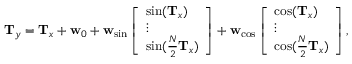Convert formula to latex. <formula><loc_0><loc_0><loc_500><loc_500>\begin{array} { r } { T _ { y } = T _ { x } + w _ { 0 } + w _ { \sin } \left [ \begin{array} { l } { \sin ( T _ { x } ) } \\ { \vdots } \\ { \sin ( \frac { N } { 2 } T _ { x } ) } \end{array} \right ] + w _ { \cos } \left [ \begin{array} { l } { \cos ( T _ { x } ) } \\ { \vdots } \\ { \cos ( \frac { N } { 2 } T _ { x } ) } \end{array} \right ] , } \end{array}</formula> 